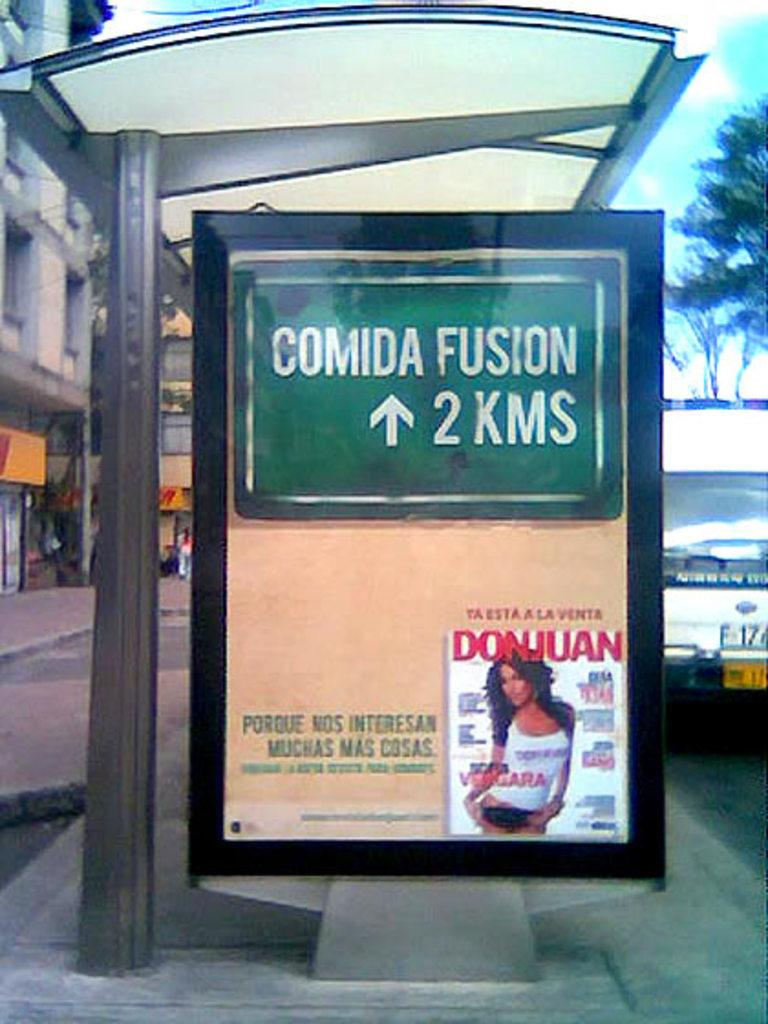<image>
Summarize the visual content of the image. A bus stop ad with the cover of the magazine DonJuan on it. 